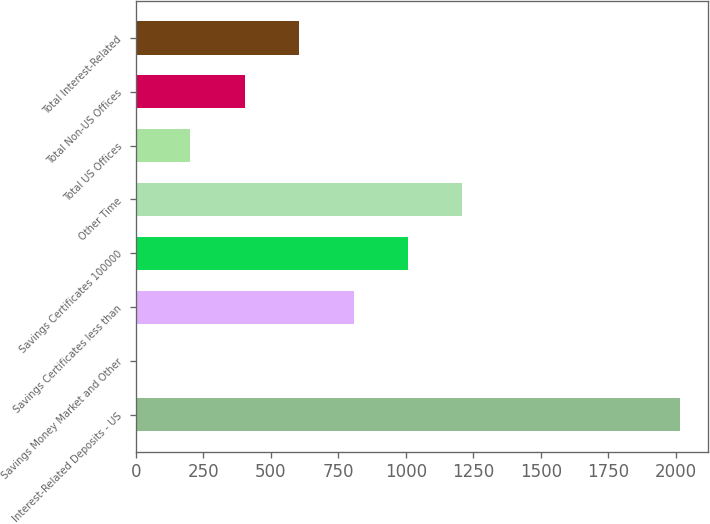Convert chart. <chart><loc_0><loc_0><loc_500><loc_500><bar_chart><fcel>Interest-Related Deposits - US<fcel>Savings Money Market and Other<fcel>Savings Certificates less than<fcel>Savings Certificates 100000<fcel>Other Time<fcel>Total US Offices<fcel>Total Non-US Offices<fcel>Total Interest-Related<nl><fcel>2016<fcel>0.08<fcel>806.44<fcel>1008.03<fcel>1209.62<fcel>201.67<fcel>403.26<fcel>604.85<nl></chart> 